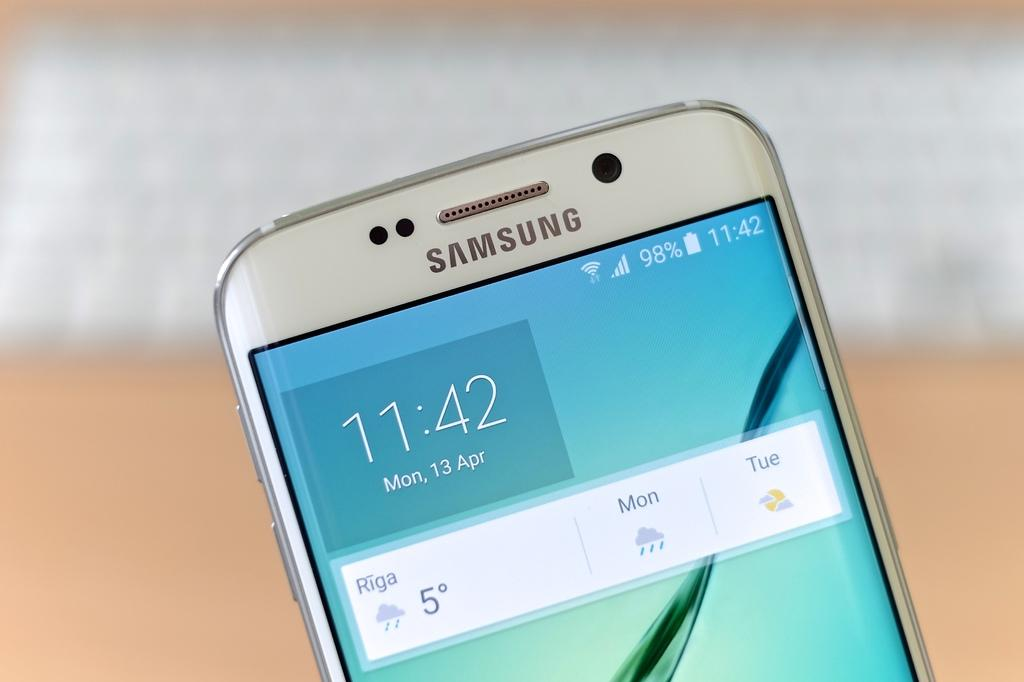<image>
Present a compact description of the photo's key features. A Samsung cell phone displays the time as 11:42. 